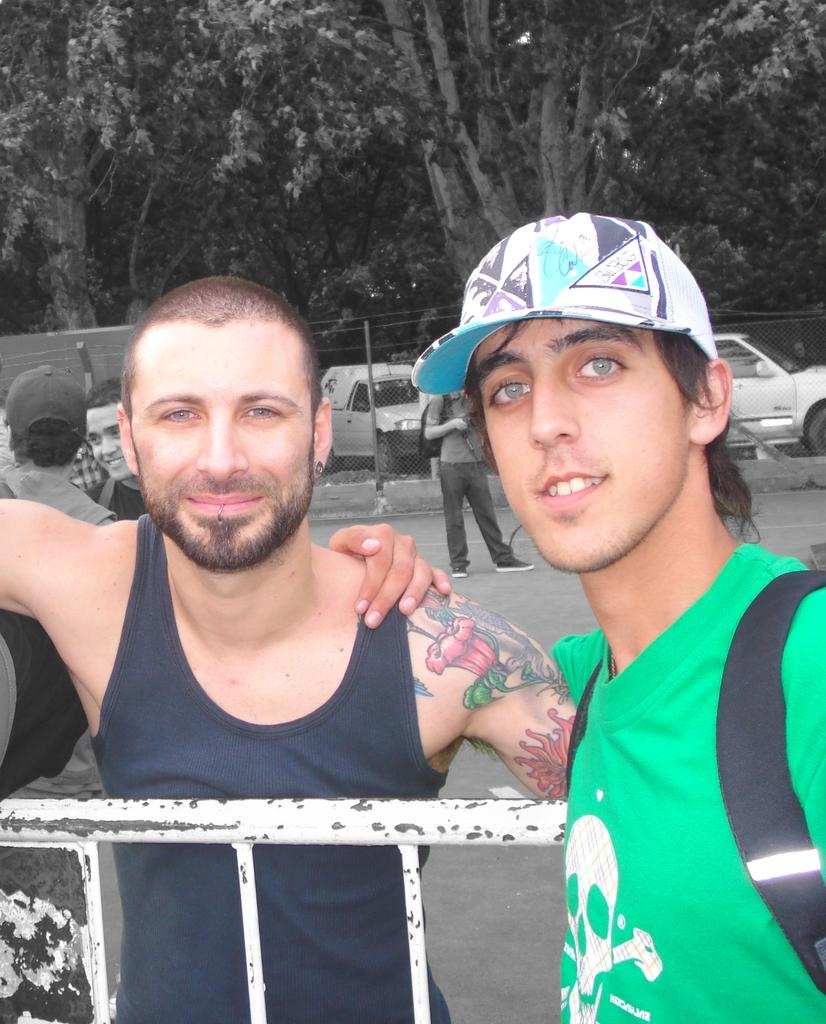What is happening in the image? There are people standing in the image. What can be seen in the background of the image? Trees are present in the background of the image. What is separating the people from the road in the image? There is a metal grill fence in the image. What is visible on the road in the image? Vehicles are visible on the road in the image. What type of instrument is being played by the people in the image? There is no instrument being played by the people in the image. Is there a bomb visible in the image? No, there is no bomb present in the image. 